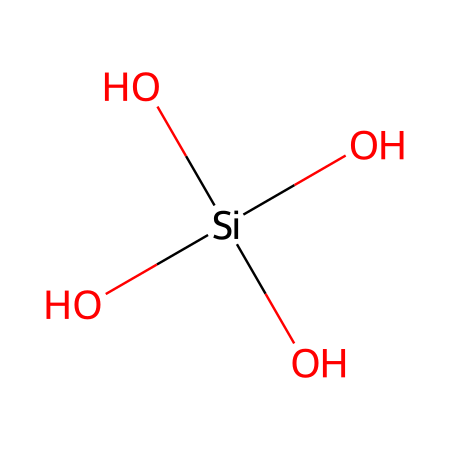how many silicon atoms are in this structure? The SMILES representation indicates one silicon atom in the structure, as it is represented by the symbol 'Si'.
Answer: one how many oxygen atoms are bonded to the silicon atom? The chemical shows four 'O' symbols directly connected to the silicon atom, indicating four oxygen atoms bonded to it.
Answer: four what is the primary function of silica in ceramics? Silica acts as a binder and increases the strength and durability of ceramics, important for structural integrity.
Answer: binder which type of ceramics commonly contain silica? Traditional ceramics, like porcelain and stoneware, typically contain silica in their composition.
Answer: porcelain what is the significance of the tetrahedral arrangement of oxygen around silicon? The tetrahedral arrangement provides structural stability and strength to the ceramic product, making it more durable.
Answer: structural stability why is silica a key ingredient for eliminating defects in ceramics? Silica’s properties allow for better flow and fusion during the firing process, reducing defects like cracks and warping.
Answer: reduces defects what happens to silica when ceramics are fired at high temperatures? Silica melts and aids in bonding constituents together, contributing to the formation of a solid and durable matrix.
Answer: aids bonding 